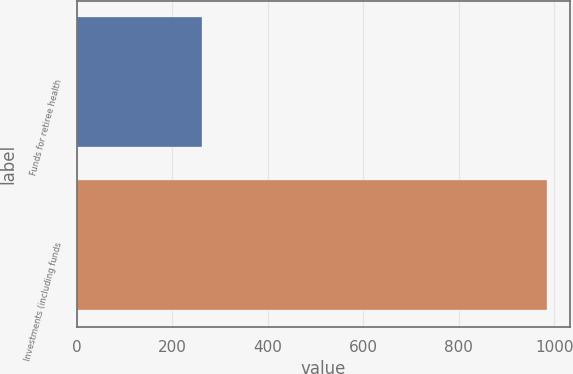Convert chart to OTSL. <chart><loc_0><loc_0><loc_500><loc_500><bar_chart><fcel>Funds for retiree health<fcel>Investments (including funds<nl><fcel>262<fcel>984<nl></chart> 